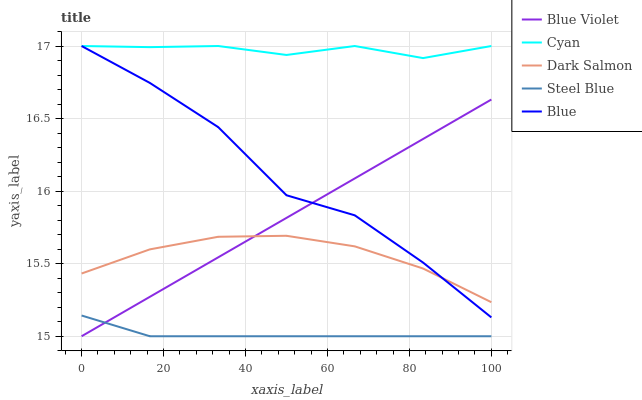Does Steel Blue have the minimum area under the curve?
Answer yes or no. Yes. Does Cyan have the maximum area under the curve?
Answer yes or no. Yes. Does Dark Salmon have the minimum area under the curve?
Answer yes or no. No. Does Dark Salmon have the maximum area under the curve?
Answer yes or no. No. Is Blue Violet the smoothest?
Answer yes or no. Yes. Is Blue the roughest?
Answer yes or no. Yes. Is Cyan the smoothest?
Answer yes or no. No. Is Cyan the roughest?
Answer yes or no. No. Does Blue Violet have the lowest value?
Answer yes or no. Yes. Does Dark Salmon have the lowest value?
Answer yes or no. No. Does Cyan have the highest value?
Answer yes or no. Yes. Does Dark Salmon have the highest value?
Answer yes or no. No. Is Steel Blue less than Cyan?
Answer yes or no. Yes. Is Blue greater than Steel Blue?
Answer yes or no. Yes. Does Steel Blue intersect Blue Violet?
Answer yes or no. Yes. Is Steel Blue less than Blue Violet?
Answer yes or no. No. Is Steel Blue greater than Blue Violet?
Answer yes or no. No. Does Steel Blue intersect Cyan?
Answer yes or no. No. 